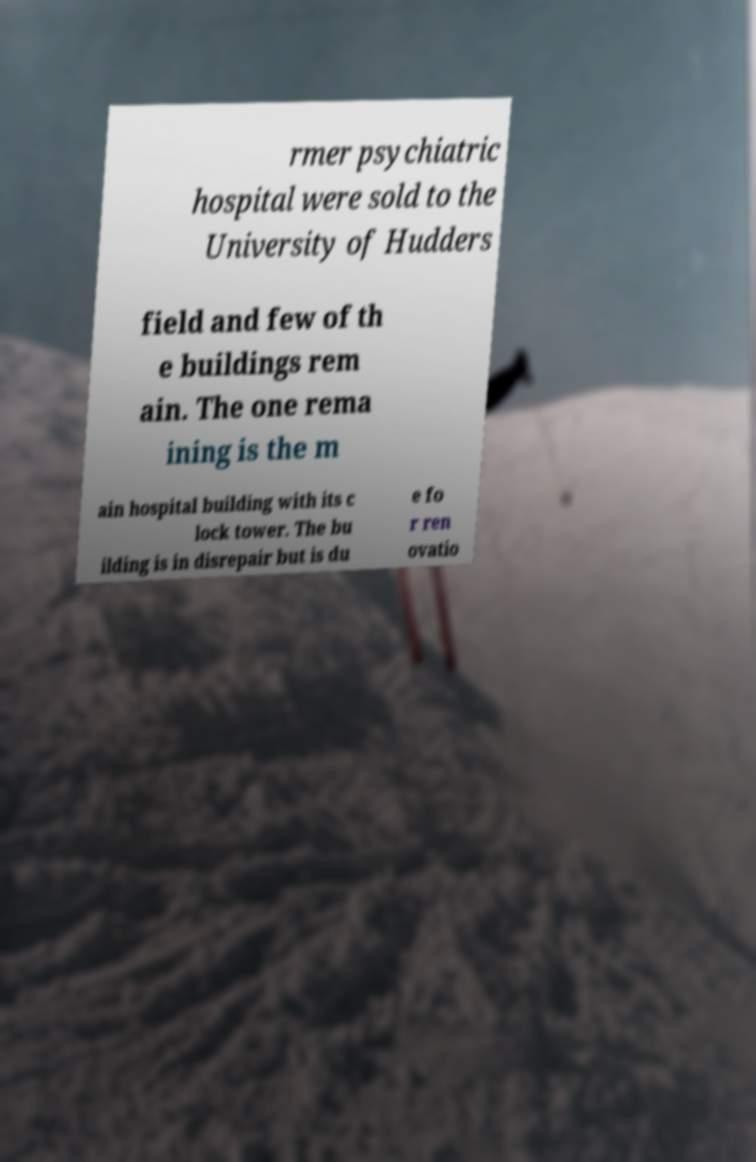Please identify and transcribe the text found in this image. rmer psychiatric hospital were sold to the University of Hudders field and few of th e buildings rem ain. The one rema ining is the m ain hospital building with its c lock tower. The bu ilding is in disrepair but is du e fo r ren ovatio 